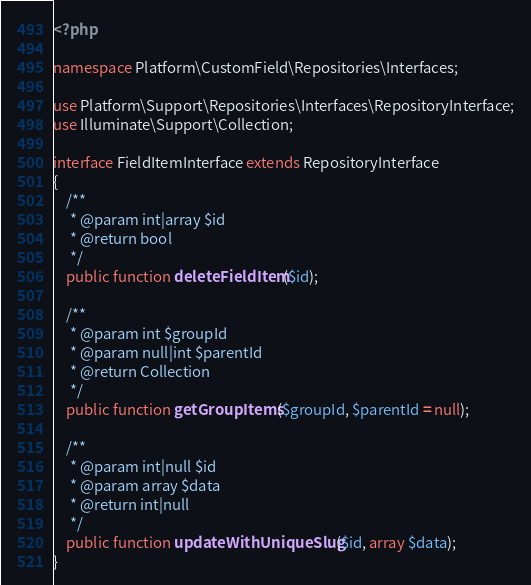<code> <loc_0><loc_0><loc_500><loc_500><_PHP_><?php

namespace Platform\CustomField\Repositories\Interfaces;

use Platform\Support\Repositories\Interfaces\RepositoryInterface;
use Illuminate\Support\Collection;

interface FieldItemInterface extends RepositoryInterface
{
    /**
     * @param int|array $id
     * @return bool
     */
    public function deleteFieldItem($id);

    /**
     * @param int $groupId
     * @param null|int $parentId
     * @return Collection
     */
    public function getGroupItems($groupId, $parentId = null);

    /**
     * @param int|null $id
     * @param array $data
     * @return int|null
     */
    public function updateWithUniqueSlug($id, array $data);
}
</code> 